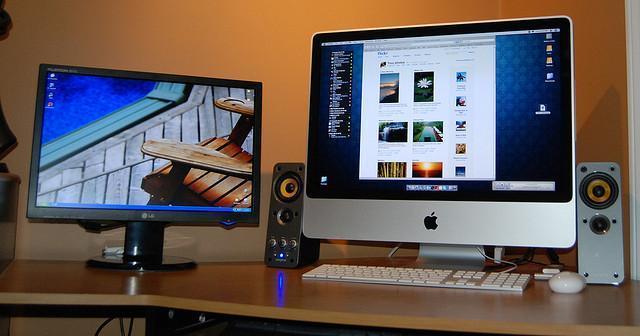How many tvs are in the photo?
Give a very brief answer. 2. 